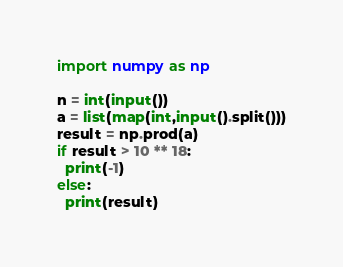Convert code to text. <code><loc_0><loc_0><loc_500><loc_500><_Python_>import numpy as np

n = int(input())
a = list(map(int,input().split()))
result = np.prod(a)
if result > 10 ** 18:
  print(-1)
else:
  print(result)</code> 